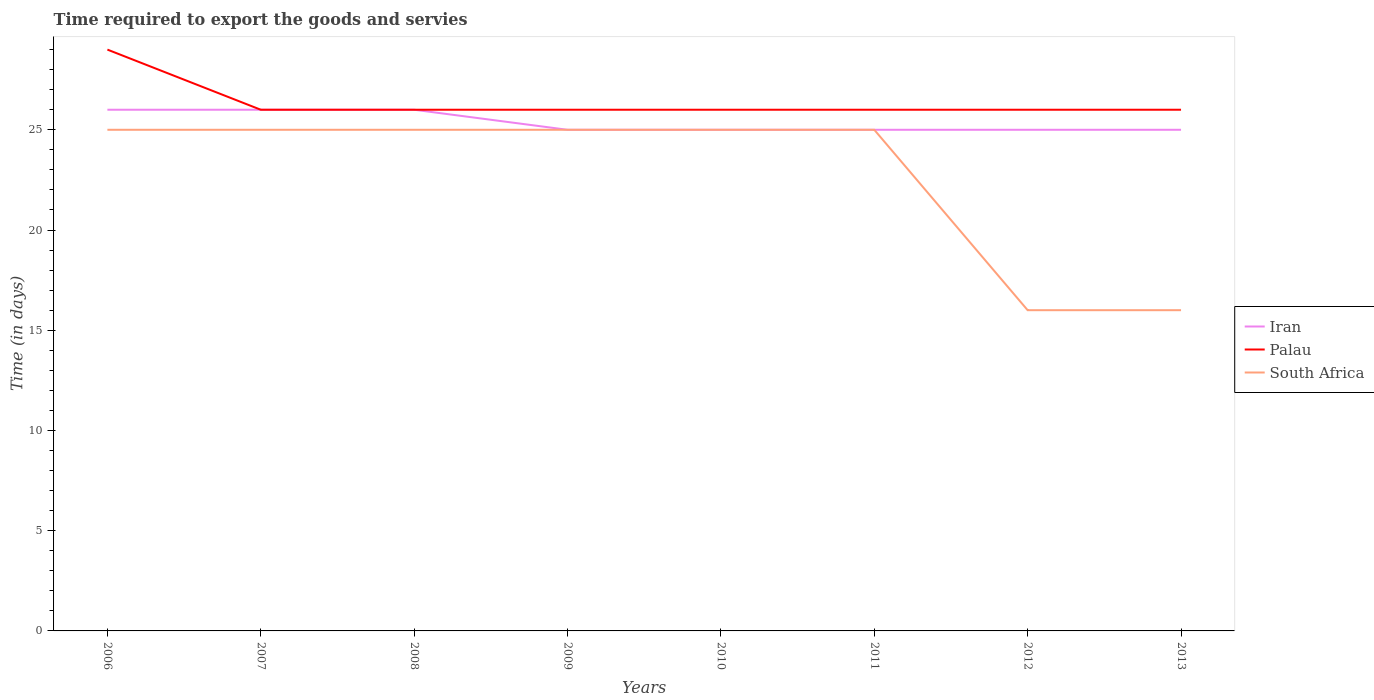Does the line corresponding to Palau intersect with the line corresponding to Iran?
Offer a terse response. Yes. Is the number of lines equal to the number of legend labels?
Provide a short and direct response. Yes. Across all years, what is the maximum number of days required to export the goods and services in Palau?
Ensure brevity in your answer.  26. What is the total number of days required to export the goods and services in Palau in the graph?
Your answer should be compact. 3. What is the difference between the highest and the second highest number of days required to export the goods and services in Iran?
Make the answer very short. 1. What is the difference between the highest and the lowest number of days required to export the goods and services in Palau?
Provide a short and direct response. 1. Is the number of days required to export the goods and services in South Africa strictly greater than the number of days required to export the goods and services in Palau over the years?
Provide a succinct answer. Yes. How many years are there in the graph?
Provide a succinct answer. 8. What is the difference between two consecutive major ticks on the Y-axis?
Make the answer very short. 5. Are the values on the major ticks of Y-axis written in scientific E-notation?
Your response must be concise. No. Does the graph contain grids?
Your response must be concise. No. How many legend labels are there?
Make the answer very short. 3. How are the legend labels stacked?
Your answer should be very brief. Vertical. What is the title of the graph?
Make the answer very short. Time required to export the goods and servies. What is the label or title of the Y-axis?
Your response must be concise. Time (in days). What is the Time (in days) in Iran in 2006?
Provide a succinct answer. 26. What is the Time (in days) of Palau in 2007?
Your answer should be very brief. 26. What is the Time (in days) of South Africa in 2007?
Your response must be concise. 25. What is the Time (in days) in Iran in 2008?
Provide a short and direct response. 26. What is the Time (in days) of Palau in 2008?
Your answer should be compact. 26. What is the Time (in days) in South Africa in 2008?
Ensure brevity in your answer.  25. What is the Time (in days) in Iran in 2009?
Provide a succinct answer. 25. What is the Time (in days) in Palau in 2009?
Keep it short and to the point. 26. What is the Time (in days) of Iran in 2010?
Your response must be concise. 25. What is the Time (in days) in Palau in 2010?
Your answer should be very brief. 26. What is the Time (in days) in South Africa in 2010?
Ensure brevity in your answer.  25. What is the Time (in days) in Palau in 2011?
Give a very brief answer. 26. What is the Time (in days) of Palau in 2012?
Make the answer very short. 26. What is the Time (in days) of South Africa in 2012?
Your answer should be compact. 16. Across all years, what is the maximum Time (in days) in South Africa?
Keep it short and to the point. 25. Across all years, what is the minimum Time (in days) of Iran?
Make the answer very short. 25. Across all years, what is the minimum Time (in days) of Palau?
Ensure brevity in your answer.  26. Across all years, what is the minimum Time (in days) in South Africa?
Make the answer very short. 16. What is the total Time (in days) of Iran in the graph?
Provide a succinct answer. 203. What is the total Time (in days) in Palau in the graph?
Give a very brief answer. 211. What is the total Time (in days) of South Africa in the graph?
Make the answer very short. 182. What is the difference between the Time (in days) of Iran in 2006 and that in 2007?
Give a very brief answer. 0. What is the difference between the Time (in days) of Palau in 2006 and that in 2007?
Make the answer very short. 3. What is the difference between the Time (in days) in South Africa in 2006 and that in 2007?
Offer a very short reply. 0. What is the difference between the Time (in days) in Iran in 2006 and that in 2008?
Your answer should be compact. 0. What is the difference between the Time (in days) of South Africa in 2006 and that in 2008?
Make the answer very short. 0. What is the difference between the Time (in days) of Palau in 2006 and that in 2009?
Keep it short and to the point. 3. What is the difference between the Time (in days) of Palau in 2006 and that in 2010?
Give a very brief answer. 3. What is the difference between the Time (in days) of South Africa in 2006 and that in 2010?
Give a very brief answer. 0. What is the difference between the Time (in days) of Palau in 2006 and that in 2011?
Give a very brief answer. 3. What is the difference between the Time (in days) in Palau in 2007 and that in 2008?
Your answer should be compact. 0. What is the difference between the Time (in days) in Iran in 2007 and that in 2009?
Your answer should be compact. 1. What is the difference between the Time (in days) of South Africa in 2007 and that in 2009?
Your answer should be very brief. 0. What is the difference between the Time (in days) of Iran in 2007 and that in 2011?
Offer a very short reply. 1. What is the difference between the Time (in days) of Palau in 2007 and that in 2011?
Offer a very short reply. 0. What is the difference between the Time (in days) in Iran in 2007 and that in 2012?
Your answer should be very brief. 1. What is the difference between the Time (in days) of South Africa in 2007 and that in 2012?
Make the answer very short. 9. What is the difference between the Time (in days) in Iran in 2007 and that in 2013?
Make the answer very short. 1. What is the difference between the Time (in days) of Palau in 2007 and that in 2013?
Ensure brevity in your answer.  0. What is the difference between the Time (in days) of Iran in 2008 and that in 2010?
Ensure brevity in your answer.  1. What is the difference between the Time (in days) of Palau in 2008 and that in 2010?
Your response must be concise. 0. What is the difference between the Time (in days) of South Africa in 2008 and that in 2010?
Give a very brief answer. 0. What is the difference between the Time (in days) of Palau in 2008 and that in 2011?
Your answer should be compact. 0. What is the difference between the Time (in days) in Iran in 2008 and that in 2012?
Make the answer very short. 1. What is the difference between the Time (in days) in Palau in 2008 and that in 2012?
Offer a terse response. 0. What is the difference between the Time (in days) in Palau in 2008 and that in 2013?
Your answer should be compact. 0. What is the difference between the Time (in days) of Iran in 2009 and that in 2010?
Provide a short and direct response. 0. What is the difference between the Time (in days) in Palau in 2009 and that in 2010?
Keep it short and to the point. 0. What is the difference between the Time (in days) of South Africa in 2009 and that in 2010?
Keep it short and to the point. 0. What is the difference between the Time (in days) in Palau in 2009 and that in 2011?
Offer a terse response. 0. What is the difference between the Time (in days) in South Africa in 2009 and that in 2011?
Give a very brief answer. 0. What is the difference between the Time (in days) in Iran in 2009 and that in 2012?
Offer a terse response. 0. What is the difference between the Time (in days) of South Africa in 2009 and that in 2012?
Offer a very short reply. 9. What is the difference between the Time (in days) in Palau in 2009 and that in 2013?
Your answer should be compact. 0. What is the difference between the Time (in days) in South Africa in 2009 and that in 2013?
Offer a terse response. 9. What is the difference between the Time (in days) in Iran in 2010 and that in 2011?
Make the answer very short. 0. What is the difference between the Time (in days) of Palau in 2010 and that in 2011?
Give a very brief answer. 0. What is the difference between the Time (in days) of Palau in 2010 and that in 2013?
Provide a short and direct response. 0. What is the difference between the Time (in days) of Palau in 2011 and that in 2012?
Your answer should be very brief. 0. What is the difference between the Time (in days) in South Africa in 2011 and that in 2012?
Offer a terse response. 9. What is the difference between the Time (in days) of Iran in 2011 and that in 2013?
Your answer should be very brief. 0. What is the difference between the Time (in days) of Palau in 2011 and that in 2013?
Keep it short and to the point. 0. What is the difference between the Time (in days) of Palau in 2012 and that in 2013?
Offer a terse response. 0. What is the difference between the Time (in days) in Iran in 2006 and the Time (in days) in Palau in 2008?
Provide a short and direct response. 0. What is the difference between the Time (in days) of Palau in 2006 and the Time (in days) of South Africa in 2008?
Ensure brevity in your answer.  4. What is the difference between the Time (in days) in Iran in 2006 and the Time (in days) in Palau in 2009?
Offer a very short reply. 0. What is the difference between the Time (in days) in Palau in 2006 and the Time (in days) in South Africa in 2009?
Your response must be concise. 4. What is the difference between the Time (in days) in Palau in 2006 and the Time (in days) in South Africa in 2010?
Keep it short and to the point. 4. What is the difference between the Time (in days) of Iran in 2006 and the Time (in days) of South Africa in 2011?
Keep it short and to the point. 1. What is the difference between the Time (in days) in Palau in 2006 and the Time (in days) in South Africa in 2011?
Give a very brief answer. 4. What is the difference between the Time (in days) in Iran in 2006 and the Time (in days) in Palau in 2012?
Your answer should be very brief. 0. What is the difference between the Time (in days) of Iran in 2006 and the Time (in days) of South Africa in 2012?
Offer a terse response. 10. What is the difference between the Time (in days) in Palau in 2006 and the Time (in days) in South Africa in 2012?
Give a very brief answer. 13. What is the difference between the Time (in days) in Iran in 2006 and the Time (in days) in South Africa in 2013?
Your answer should be very brief. 10. What is the difference between the Time (in days) in Iran in 2007 and the Time (in days) in Palau in 2008?
Make the answer very short. 0. What is the difference between the Time (in days) in Iran in 2007 and the Time (in days) in South Africa in 2008?
Make the answer very short. 1. What is the difference between the Time (in days) in Palau in 2007 and the Time (in days) in South Africa in 2009?
Your answer should be very brief. 1. What is the difference between the Time (in days) in Iran in 2007 and the Time (in days) in Palau in 2010?
Give a very brief answer. 0. What is the difference between the Time (in days) in Iran in 2007 and the Time (in days) in Palau in 2011?
Provide a short and direct response. 0. What is the difference between the Time (in days) of Iran in 2007 and the Time (in days) of South Africa in 2011?
Keep it short and to the point. 1. What is the difference between the Time (in days) in Iran in 2007 and the Time (in days) in South Africa in 2012?
Your answer should be compact. 10. What is the difference between the Time (in days) of Palau in 2007 and the Time (in days) of South Africa in 2012?
Offer a very short reply. 10. What is the difference between the Time (in days) of Iran in 2007 and the Time (in days) of Palau in 2013?
Your answer should be very brief. 0. What is the difference between the Time (in days) of Palau in 2007 and the Time (in days) of South Africa in 2013?
Your answer should be compact. 10. What is the difference between the Time (in days) in Palau in 2008 and the Time (in days) in South Africa in 2009?
Your response must be concise. 1. What is the difference between the Time (in days) in Iran in 2008 and the Time (in days) in South Africa in 2010?
Your answer should be compact. 1. What is the difference between the Time (in days) in Palau in 2008 and the Time (in days) in South Africa in 2010?
Offer a terse response. 1. What is the difference between the Time (in days) in Iran in 2008 and the Time (in days) in Palau in 2011?
Keep it short and to the point. 0. What is the difference between the Time (in days) in Palau in 2008 and the Time (in days) in South Africa in 2011?
Provide a short and direct response. 1. What is the difference between the Time (in days) of Palau in 2008 and the Time (in days) of South Africa in 2012?
Provide a short and direct response. 10. What is the difference between the Time (in days) of Iran in 2008 and the Time (in days) of Palau in 2013?
Give a very brief answer. 0. What is the difference between the Time (in days) of Iran in 2008 and the Time (in days) of South Africa in 2013?
Offer a very short reply. 10. What is the difference between the Time (in days) in Palau in 2008 and the Time (in days) in South Africa in 2013?
Ensure brevity in your answer.  10. What is the difference between the Time (in days) in Iran in 2009 and the Time (in days) in South Africa in 2010?
Provide a short and direct response. 0. What is the difference between the Time (in days) of Iran in 2009 and the Time (in days) of Palau in 2011?
Offer a terse response. -1. What is the difference between the Time (in days) in Iran in 2009 and the Time (in days) in South Africa in 2011?
Offer a terse response. 0. What is the difference between the Time (in days) of Iran in 2009 and the Time (in days) of South Africa in 2013?
Keep it short and to the point. 9. What is the difference between the Time (in days) of Palau in 2009 and the Time (in days) of South Africa in 2013?
Provide a short and direct response. 10. What is the difference between the Time (in days) in Iran in 2010 and the Time (in days) in South Africa in 2011?
Give a very brief answer. 0. What is the difference between the Time (in days) in Palau in 2010 and the Time (in days) in South Africa in 2011?
Make the answer very short. 1. What is the difference between the Time (in days) in Iran in 2010 and the Time (in days) in Palau in 2012?
Your response must be concise. -1. What is the difference between the Time (in days) of Iran in 2010 and the Time (in days) of South Africa in 2012?
Ensure brevity in your answer.  9. What is the difference between the Time (in days) in Palau in 2010 and the Time (in days) in South Africa in 2012?
Keep it short and to the point. 10. What is the difference between the Time (in days) of Iran in 2010 and the Time (in days) of South Africa in 2013?
Make the answer very short. 9. What is the difference between the Time (in days) in Palau in 2010 and the Time (in days) in South Africa in 2013?
Your answer should be very brief. 10. What is the difference between the Time (in days) of Iran in 2011 and the Time (in days) of Palau in 2012?
Offer a terse response. -1. What is the difference between the Time (in days) in Palau in 2011 and the Time (in days) in South Africa in 2012?
Keep it short and to the point. 10. What is the difference between the Time (in days) in Iran in 2011 and the Time (in days) in Palau in 2013?
Offer a terse response. -1. What is the difference between the Time (in days) of Iran in 2011 and the Time (in days) of South Africa in 2013?
Offer a very short reply. 9. What is the difference between the Time (in days) of Palau in 2011 and the Time (in days) of South Africa in 2013?
Ensure brevity in your answer.  10. What is the difference between the Time (in days) in Iran in 2012 and the Time (in days) in Palau in 2013?
Your response must be concise. -1. What is the average Time (in days) of Iran per year?
Make the answer very short. 25.38. What is the average Time (in days) of Palau per year?
Provide a succinct answer. 26.38. What is the average Time (in days) in South Africa per year?
Your answer should be very brief. 22.75. In the year 2006, what is the difference between the Time (in days) in Palau and Time (in days) in South Africa?
Your answer should be very brief. 4. In the year 2007, what is the difference between the Time (in days) in Iran and Time (in days) in Palau?
Keep it short and to the point. 0. In the year 2010, what is the difference between the Time (in days) of Iran and Time (in days) of Palau?
Your answer should be compact. -1. In the year 2011, what is the difference between the Time (in days) of Iran and Time (in days) of Palau?
Your response must be concise. -1. In the year 2011, what is the difference between the Time (in days) of Iran and Time (in days) of South Africa?
Provide a short and direct response. 0. In the year 2011, what is the difference between the Time (in days) in Palau and Time (in days) in South Africa?
Provide a short and direct response. 1. In the year 2012, what is the difference between the Time (in days) of Iran and Time (in days) of Palau?
Offer a terse response. -1. In the year 2012, what is the difference between the Time (in days) in Iran and Time (in days) in South Africa?
Provide a succinct answer. 9. In the year 2013, what is the difference between the Time (in days) of Iran and Time (in days) of Palau?
Your answer should be very brief. -1. In the year 2013, what is the difference between the Time (in days) of Iran and Time (in days) of South Africa?
Offer a terse response. 9. In the year 2013, what is the difference between the Time (in days) of Palau and Time (in days) of South Africa?
Provide a short and direct response. 10. What is the ratio of the Time (in days) in Iran in 2006 to that in 2007?
Provide a short and direct response. 1. What is the ratio of the Time (in days) of Palau in 2006 to that in 2007?
Ensure brevity in your answer.  1.12. What is the ratio of the Time (in days) in South Africa in 2006 to that in 2007?
Make the answer very short. 1. What is the ratio of the Time (in days) of Palau in 2006 to that in 2008?
Offer a terse response. 1.12. What is the ratio of the Time (in days) in South Africa in 2006 to that in 2008?
Make the answer very short. 1. What is the ratio of the Time (in days) in Palau in 2006 to that in 2009?
Ensure brevity in your answer.  1.12. What is the ratio of the Time (in days) of South Africa in 2006 to that in 2009?
Ensure brevity in your answer.  1. What is the ratio of the Time (in days) in Iran in 2006 to that in 2010?
Your answer should be compact. 1.04. What is the ratio of the Time (in days) in Palau in 2006 to that in 2010?
Offer a very short reply. 1.12. What is the ratio of the Time (in days) of South Africa in 2006 to that in 2010?
Make the answer very short. 1. What is the ratio of the Time (in days) in Iran in 2006 to that in 2011?
Offer a terse response. 1.04. What is the ratio of the Time (in days) of Palau in 2006 to that in 2011?
Your answer should be compact. 1.12. What is the ratio of the Time (in days) of Palau in 2006 to that in 2012?
Offer a very short reply. 1.12. What is the ratio of the Time (in days) of South Africa in 2006 to that in 2012?
Your answer should be compact. 1.56. What is the ratio of the Time (in days) in Palau in 2006 to that in 2013?
Make the answer very short. 1.12. What is the ratio of the Time (in days) in South Africa in 2006 to that in 2013?
Make the answer very short. 1.56. What is the ratio of the Time (in days) in Iran in 2007 to that in 2008?
Your answer should be compact. 1. What is the ratio of the Time (in days) of South Africa in 2007 to that in 2008?
Your answer should be compact. 1. What is the ratio of the Time (in days) in Palau in 2007 to that in 2009?
Give a very brief answer. 1. What is the ratio of the Time (in days) in Iran in 2007 to that in 2010?
Provide a succinct answer. 1.04. What is the ratio of the Time (in days) in Palau in 2007 to that in 2011?
Provide a short and direct response. 1. What is the ratio of the Time (in days) in Palau in 2007 to that in 2012?
Make the answer very short. 1. What is the ratio of the Time (in days) of South Africa in 2007 to that in 2012?
Give a very brief answer. 1.56. What is the ratio of the Time (in days) in Palau in 2007 to that in 2013?
Offer a very short reply. 1. What is the ratio of the Time (in days) of South Africa in 2007 to that in 2013?
Offer a terse response. 1.56. What is the ratio of the Time (in days) in Iran in 2008 to that in 2009?
Offer a terse response. 1.04. What is the ratio of the Time (in days) in Palau in 2008 to that in 2009?
Provide a succinct answer. 1. What is the ratio of the Time (in days) in South Africa in 2008 to that in 2010?
Your answer should be very brief. 1. What is the ratio of the Time (in days) in Palau in 2008 to that in 2011?
Provide a succinct answer. 1. What is the ratio of the Time (in days) in Palau in 2008 to that in 2012?
Give a very brief answer. 1. What is the ratio of the Time (in days) of South Africa in 2008 to that in 2012?
Make the answer very short. 1.56. What is the ratio of the Time (in days) in South Africa in 2008 to that in 2013?
Your answer should be compact. 1.56. What is the ratio of the Time (in days) of Iran in 2009 to that in 2010?
Give a very brief answer. 1. What is the ratio of the Time (in days) of Palau in 2009 to that in 2010?
Provide a succinct answer. 1. What is the ratio of the Time (in days) in Palau in 2009 to that in 2011?
Ensure brevity in your answer.  1. What is the ratio of the Time (in days) of South Africa in 2009 to that in 2011?
Provide a short and direct response. 1. What is the ratio of the Time (in days) of South Africa in 2009 to that in 2012?
Offer a terse response. 1.56. What is the ratio of the Time (in days) of Iran in 2009 to that in 2013?
Offer a terse response. 1. What is the ratio of the Time (in days) in Palau in 2009 to that in 2013?
Ensure brevity in your answer.  1. What is the ratio of the Time (in days) in South Africa in 2009 to that in 2013?
Make the answer very short. 1.56. What is the ratio of the Time (in days) in Iran in 2010 to that in 2011?
Offer a terse response. 1. What is the ratio of the Time (in days) in Palau in 2010 to that in 2012?
Keep it short and to the point. 1. What is the ratio of the Time (in days) in South Africa in 2010 to that in 2012?
Give a very brief answer. 1.56. What is the ratio of the Time (in days) of Iran in 2010 to that in 2013?
Give a very brief answer. 1. What is the ratio of the Time (in days) of South Africa in 2010 to that in 2013?
Give a very brief answer. 1.56. What is the ratio of the Time (in days) in Palau in 2011 to that in 2012?
Offer a terse response. 1. What is the ratio of the Time (in days) in South Africa in 2011 to that in 2012?
Keep it short and to the point. 1.56. What is the ratio of the Time (in days) of Iran in 2011 to that in 2013?
Ensure brevity in your answer.  1. What is the ratio of the Time (in days) of Palau in 2011 to that in 2013?
Make the answer very short. 1. What is the ratio of the Time (in days) of South Africa in 2011 to that in 2013?
Provide a succinct answer. 1.56. What is the ratio of the Time (in days) of Iran in 2012 to that in 2013?
Your answer should be very brief. 1. What is the ratio of the Time (in days) in Palau in 2012 to that in 2013?
Your response must be concise. 1. What is the difference between the highest and the lowest Time (in days) in Iran?
Offer a very short reply. 1. What is the difference between the highest and the lowest Time (in days) in South Africa?
Offer a terse response. 9. 